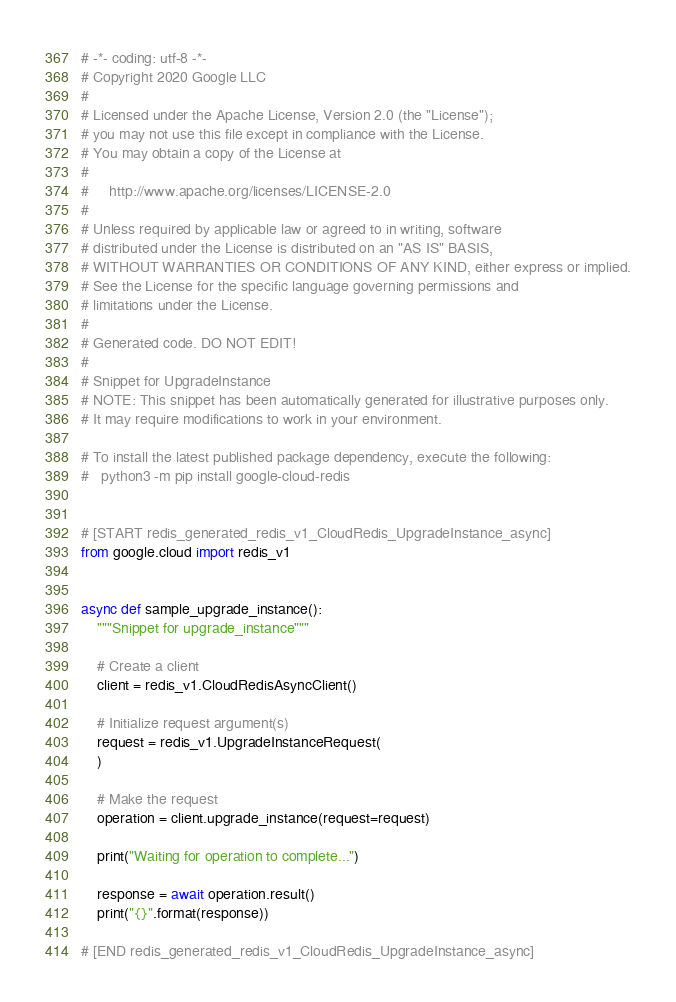Convert code to text. <code><loc_0><loc_0><loc_500><loc_500><_Python_># -*- coding: utf-8 -*-
# Copyright 2020 Google LLC
#
# Licensed under the Apache License, Version 2.0 (the "License");
# you may not use this file except in compliance with the License.
# You may obtain a copy of the License at
#
#     http://www.apache.org/licenses/LICENSE-2.0
#
# Unless required by applicable law or agreed to in writing, software
# distributed under the License is distributed on an "AS IS" BASIS,
# WITHOUT WARRANTIES OR CONDITIONS OF ANY KIND, either express or implied.
# See the License for the specific language governing permissions and
# limitations under the License.
#
# Generated code. DO NOT EDIT!
#
# Snippet for UpgradeInstance
# NOTE: This snippet has been automatically generated for illustrative purposes only.
# It may require modifications to work in your environment.

# To install the latest published package dependency, execute the following:
#   python3 -m pip install google-cloud-redis


# [START redis_generated_redis_v1_CloudRedis_UpgradeInstance_async]
from google.cloud import redis_v1


async def sample_upgrade_instance():
    """Snippet for upgrade_instance"""

    # Create a client
    client = redis_v1.CloudRedisAsyncClient()

    # Initialize request argument(s)
    request = redis_v1.UpgradeInstanceRequest(
    )

    # Make the request
    operation = client.upgrade_instance(request=request)

    print("Waiting for operation to complete...")

    response = await operation.result()
    print("{}".format(response))

# [END redis_generated_redis_v1_CloudRedis_UpgradeInstance_async]
</code> 